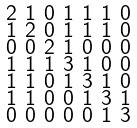Convert formula to latex. <formula><loc_0><loc_0><loc_500><loc_500>\begin{smallmatrix} 2 & 1 & 0 & 1 & 1 & 1 & 0 \\ 1 & 2 & 0 & 1 & 1 & 1 & 0 \\ 0 & 0 & 2 & 1 & 0 & 0 & 0 \\ 1 & 1 & 1 & 3 & 1 & 0 & 0 \\ 1 & 1 & 0 & 1 & 3 & 1 & 0 \\ 1 & 1 & 0 & 0 & 1 & 3 & 1 \\ 0 & 0 & 0 & 0 & 0 & 1 & 3 \end{smallmatrix}</formula> 